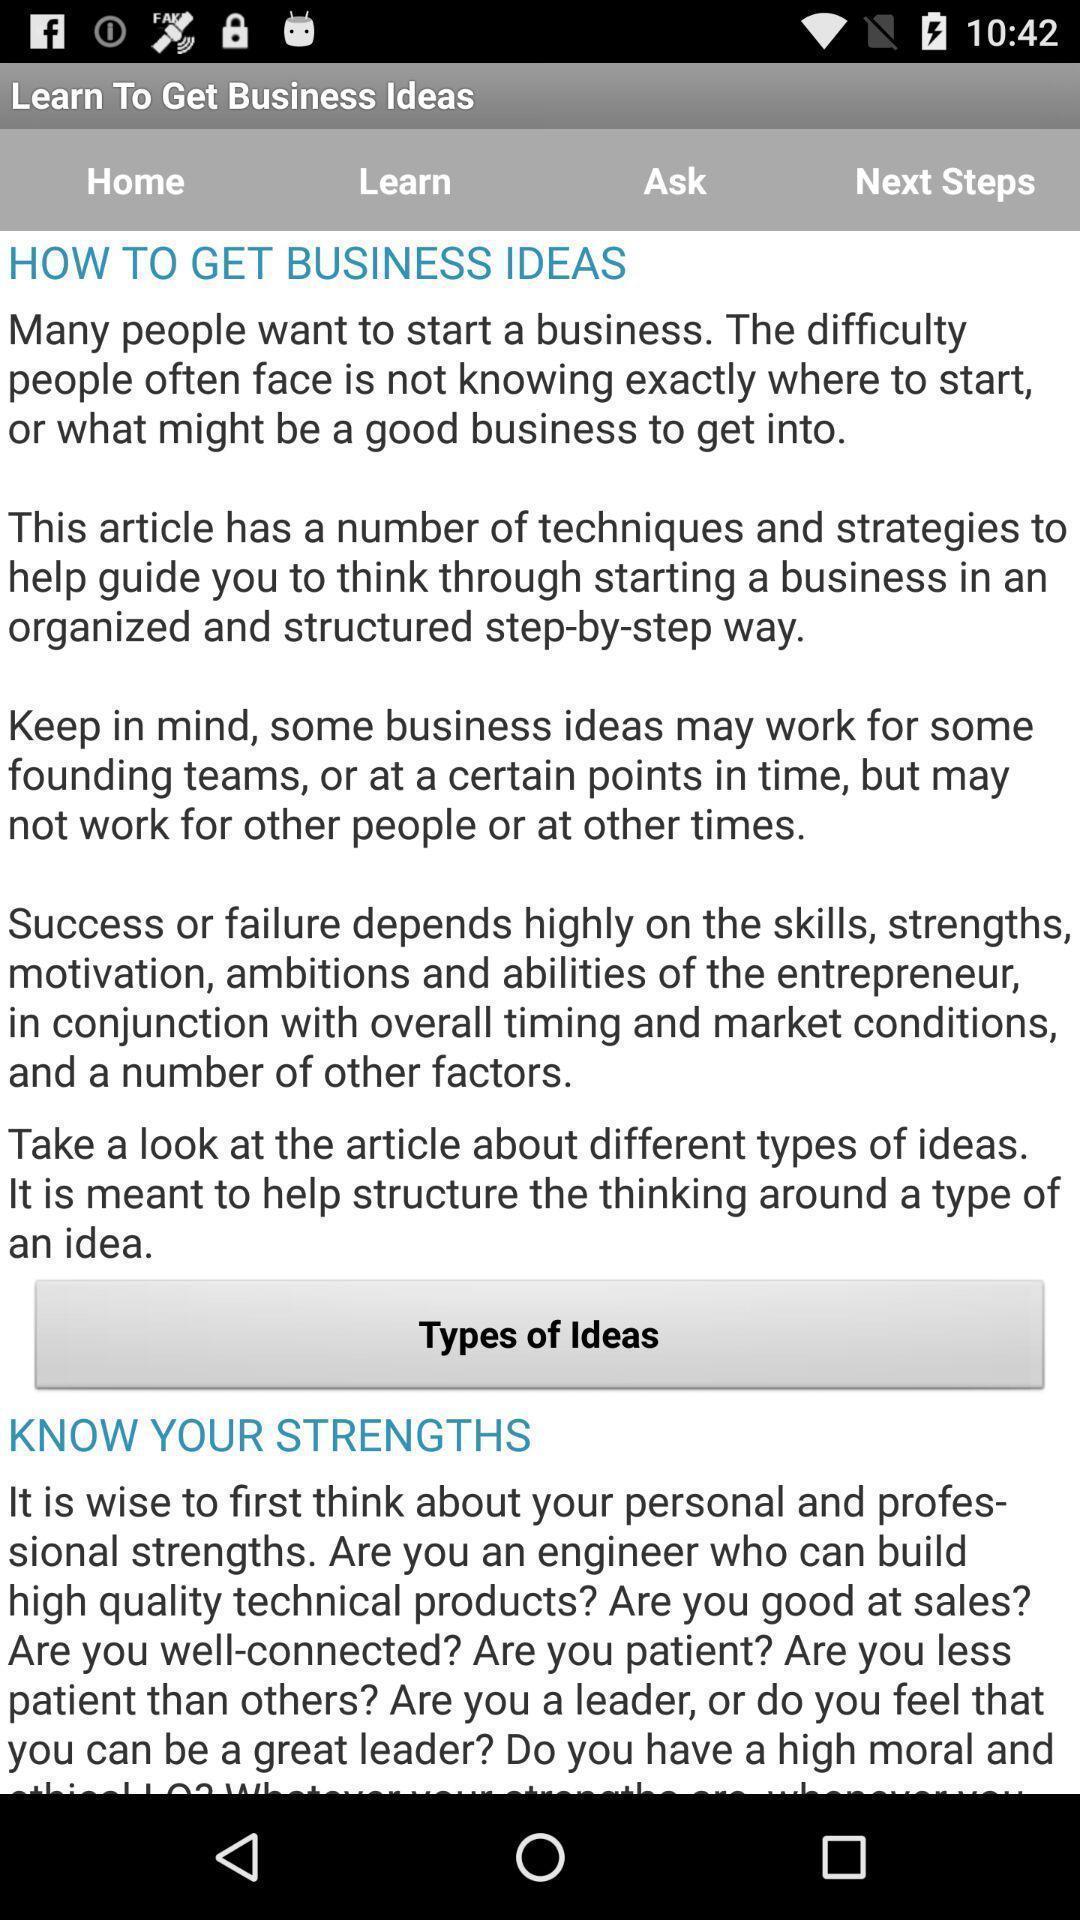Please provide a description for this image. Screen displaying business ideas information. 